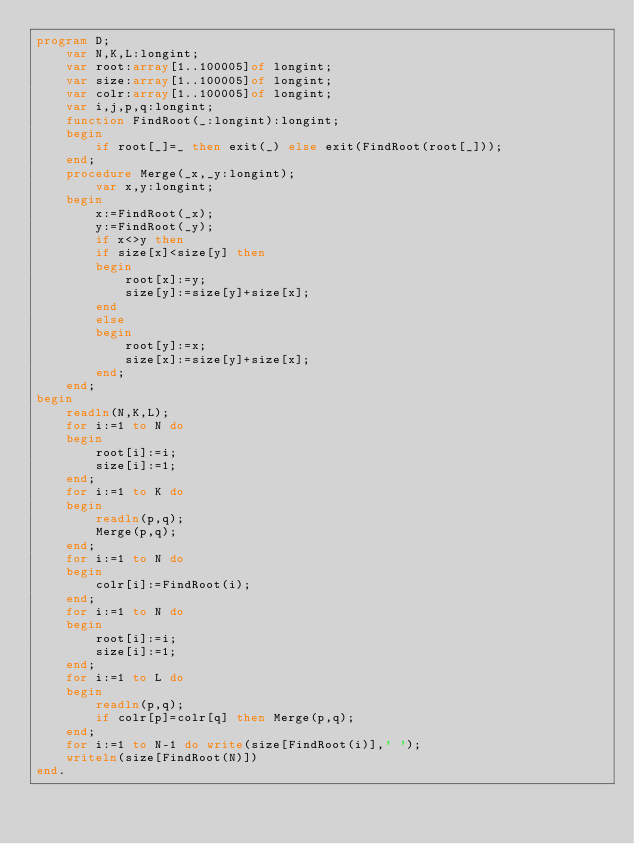Convert code to text. <code><loc_0><loc_0><loc_500><loc_500><_Pascal_>program D;
    var N,K,L:longint;
    var root:array[1..100005]of longint;
    var size:array[1..100005]of longint;
    var colr:array[1..100005]of longint;
    var i,j,p,q:longint;
    function FindRoot(_:longint):longint;
    begin
        if root[_]=_ then exit(_) else exit(FindRoot(root[_]));
    end;
    procedure Merge(_x,_y:longint);
        var x,y:longint;
    begin
        x:=FindRoot(_x);
        y:=FindRoot(_y);
        if x<>y then
        if size[x]<size[y] then
        begin
            root[x]:=y;
            size[y]:=size[y]+size[x];
        end
        else
        begin
            root[y]:=x;
            size[x]:=size[y]+size[x];
        end; 
    end;
begin
    readln(N,K,L);
    for i:=1 to N do
    begin
        root[i]:=i;
        size[i]:=1;
    end;
    for i:=1 to K do
    begin
        readln(p,q);
        Merge(p,q);
    end;
    for i:=1 to N do
    begin
        colr[i]:=FindRoot(i);
    end;
    for i:=1 to N do
    begin
        root[i]:=i;
        size[i]:=1;
    end;    
    for i:=1 to L do
    begin
        readln(p,q);
        if colr[p]=colr[q] then Merge(p,q);
    end;
    for i:=1 to N-1 do write(size[FindRoot(i)],' ');
    writeln(size[FindRoot(N)])
end.</code> 